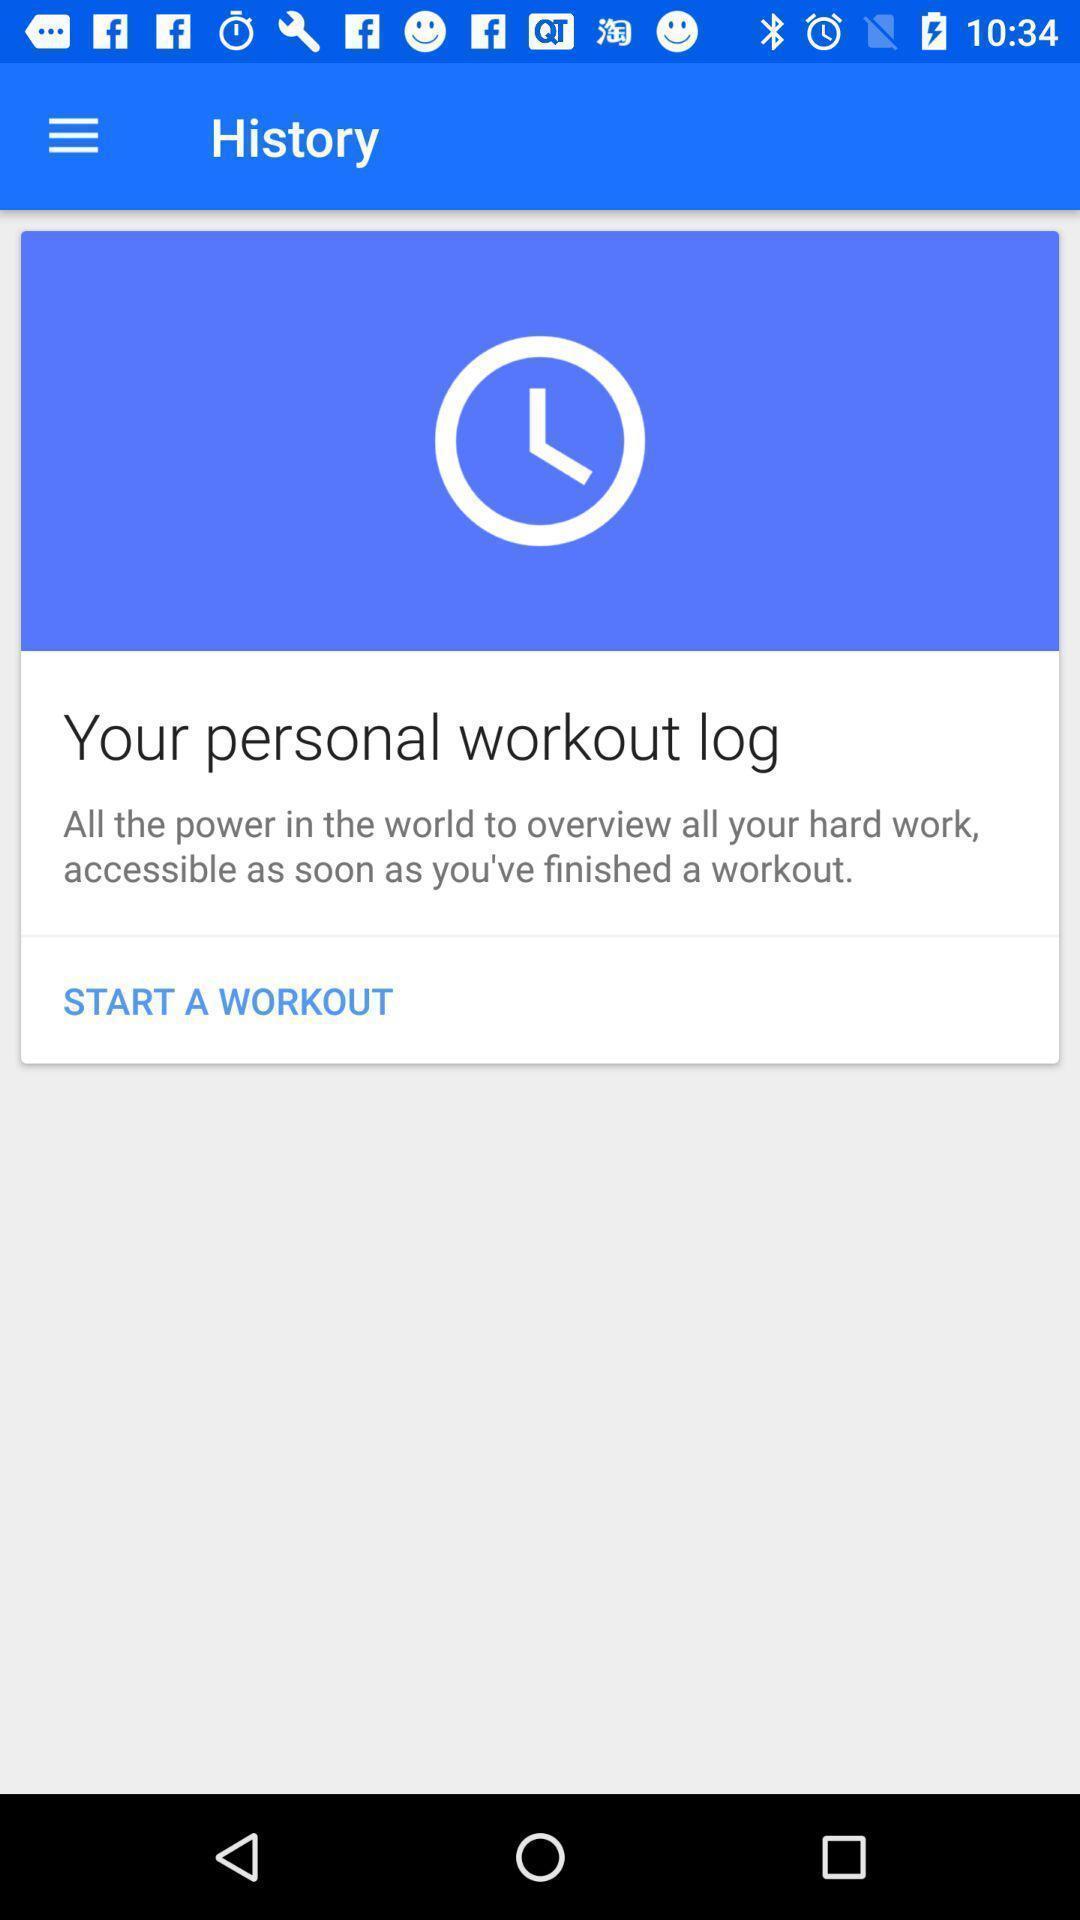Tell me what you see in this picture. Screen displaying contents of a fitness application. 